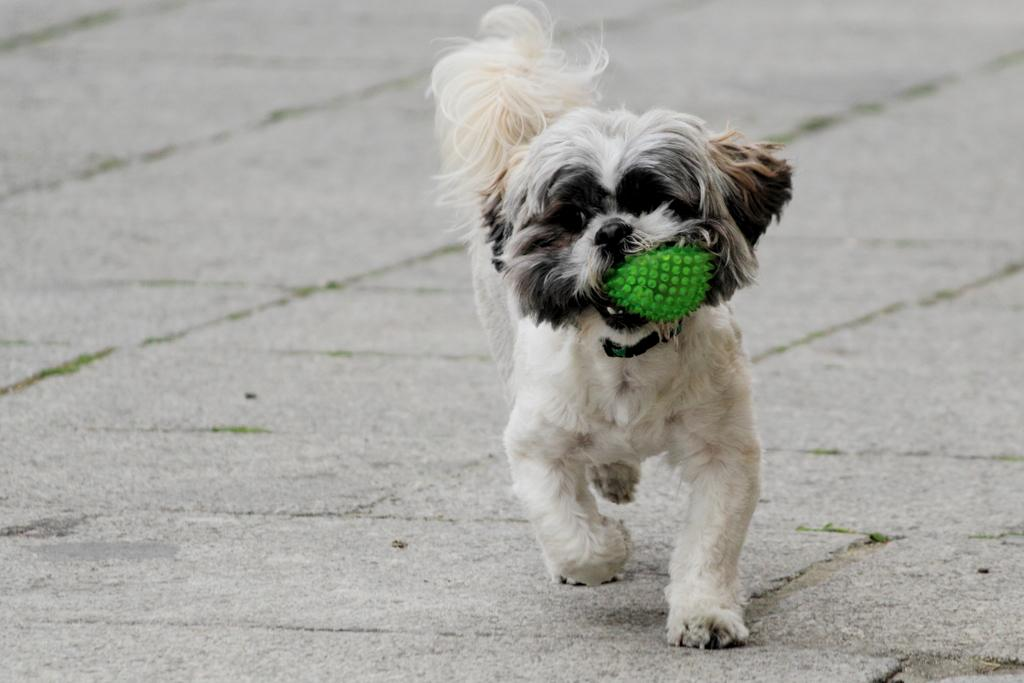What animal can be seen in the image? There is a dog in the image. What is the dog doing in the image? The dog is running on the ground. What type of jam is the dog spreading on the end of the brush in the image? There is no jam or brush present in the image; it only features a dog running on the ground. 